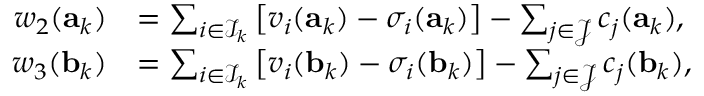Convert formula to latex. <formula><loc_0><loc_0><loc_500><loc_500>\begin{array} { r l } { w _ { 2 } ( a _ { k } ) } & { = \sum _ { i \in \mathcal { I } _ { k } } \left [ v _ { i } ( a _ { k } ) - \sigma _ { i } ( a _ { k } ) \right ] - \sum _ { j \in \mathcal { J } } c _ { j } ( a _ { k } ) , } \\ { w _ { 3 } ( b _ { k } ) } & { = \sum _ { i \in \mathcal { I } _ { k } } \left [ v _ { i } ( b _ { k } ) - \sigma _ { i } ( b _ { k } ) \right ] - \sum _ { j \in \mathcal { J } } c _ { j } ( b _ { k } ) , } \end{array}</formula> 